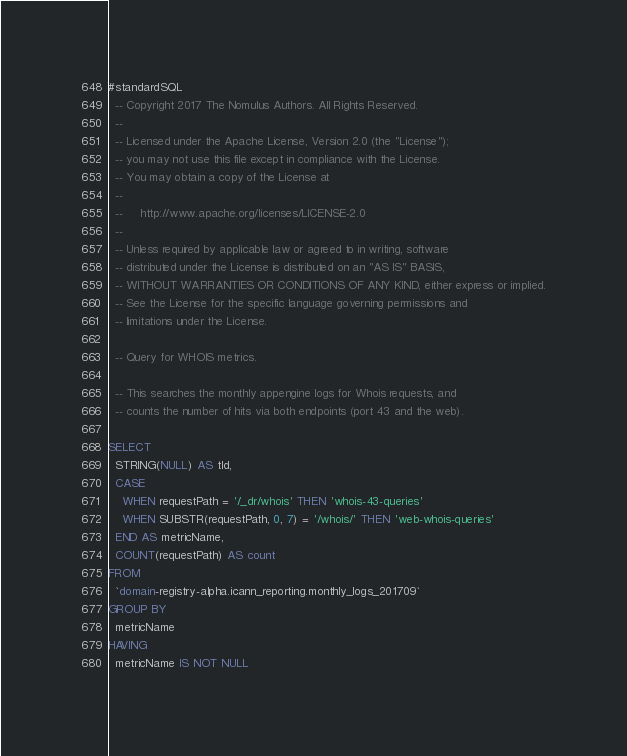Convert code to text. <code><loc_0><loc_0><loc_500><loc_500><_SQL_>#standardSQL
  -- Copyright 2017 The Nomulus Authors. All Rights Reserved.
  --
  -- Licensed under the Apache License, Version 2.0 (the "License");
  -- you may not use this file except in compliance with the License.
  -- You may obtain a copy of the License at
  --
  --     http://www.apache.org/licenses/LICENSE-2.0
  --
  -- Unless required by applicable law or agreed to in writing, software
  -- distributed under the License is distributed on an "AS IS" BASIS,
  -- WITHOUT WARRANTIES OR CONDITIONS OF ANY KIND, either express or implied.
  -- See the License for the specific language governing permissions and
  -- limitations under the License.

  -- Query for WHOIS metrics.

  -- This searches the monthly appengine logs for Whois requests, and
  -- counts the number of hits via both endpoints (port 43 and the web).

SELECT
  STRING(NULL) AS tld,
  CASE
    WHEN requestPath = '/_dr/whois' THEN 'whois-43-queries'
    WHEN SUBSTR(requestPath, 0, 7) = '/whois/' THEN 'web-whois-queries'
  END AS metricName,
  COUNT(requestPath) AS count
FROM
  `domain-registry-alpha.icann_reporting.monthly_logs_201709`
GROUP BY
  metricName
HAVING
  metricName IS NOT NULL
</code> 